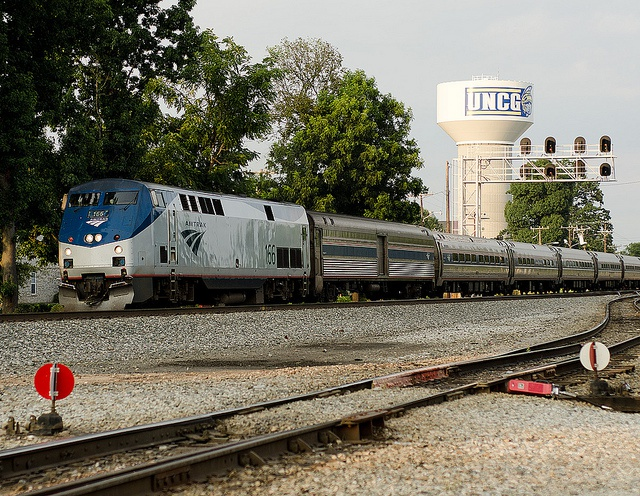Describe the objects in this image and their specific colors. I can see train in black, darkgray, gray, and darkgreen tones, stop sign in black, brown, darkgray, and maroon tones, traffic light in black, lightgray, darkgray, and olive tones, traffic light in black, olive, gray, and maroon tones, and traffic light in black, maroon, and gray tones in this image. 